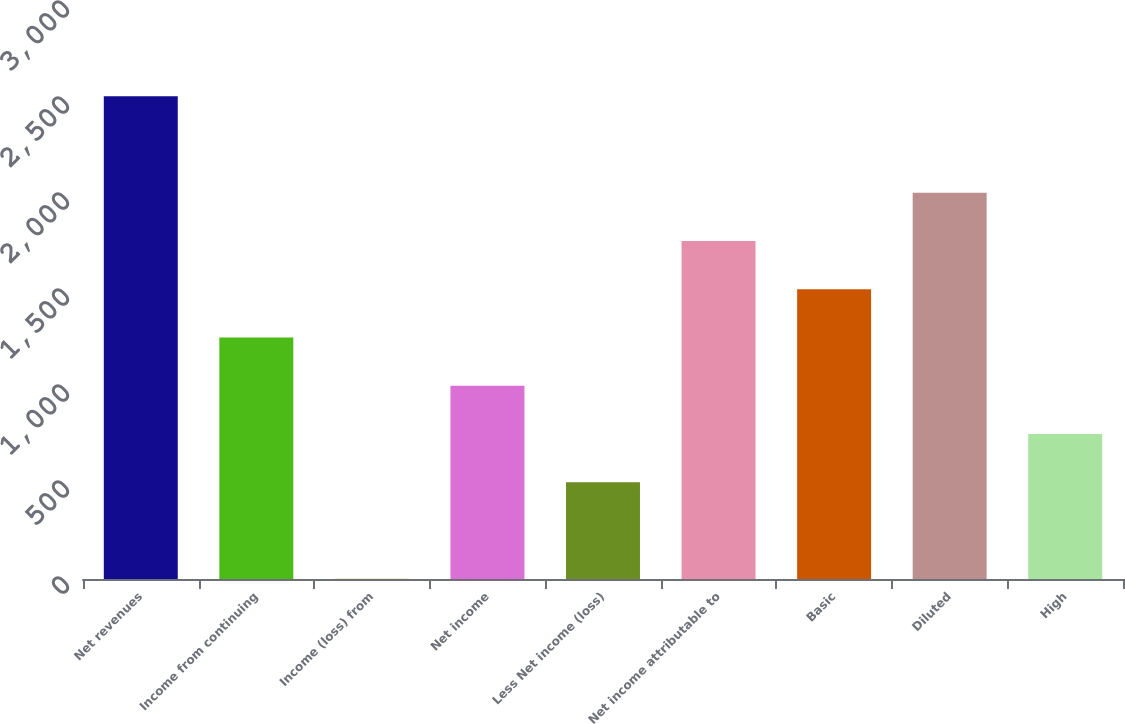Convert chart to OTSL. <chart><loc_0><loc_0><loc_500><loc_500><bar_chart><fcel>Net revenues<fcel>Income from continuing<fcel>Income (loss) from<fcel>Net income<fcel>Less Net income (loss)<fcel>Net income attributable to<fcel>Basic<fcel>Diluted<fcel>High<nl><fcel>2514<fcel>1257.5<fcel>1<fcel>1006.2<fcel>503.6<fcel>1760.1<fcel>1508.8<fcel>2011.4<fcel>754.9<nl></chart> 